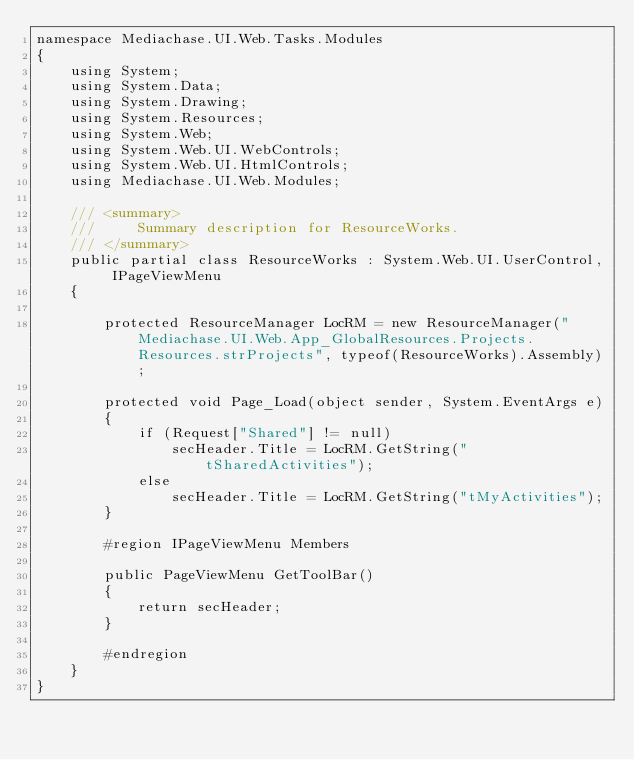<code> <loc_0><loc_0><loc_500><loc_500><_C#_>namespace Mediachase.UI.Web.Tasks.Modules
{
	using System;
	using System.Data;
	using System.Drawing;
	using System.Resources;
	using System.Web;
	using System.Web.UI.WebControls;
	using System.Web.UI.HtmlControls;
	using Mediachase.UI.Web.Modules;

	/// <summary>
	///		Summary description for ResourceWorks.
	/// </summary>
	public partial class ResourceWorks : System.Web.UI.UserControl, IPageViewMenu
	{

		protected ResourceManager LocRM = new ResourceManager("Mediachase.UI.Web.App_GlobalResources.Projects.Resources.strProjects", typeof(ResourceWorks).Assembly);

		protected void Page_Load(object sender, System.EventArgs e)
		{
			if (Request["Shared"] != null)
				secHeader.Title = LocRM.GetString("tSharedActivities");
			else
				secHeader.Title = LocRM.GetString("tMyActivities");
		}

		#region IPageViewMenu Members

		public PageViewMenu GetToolBar()
		{
			return secHeader;
		}

		#endregion
	}
}
</code> 